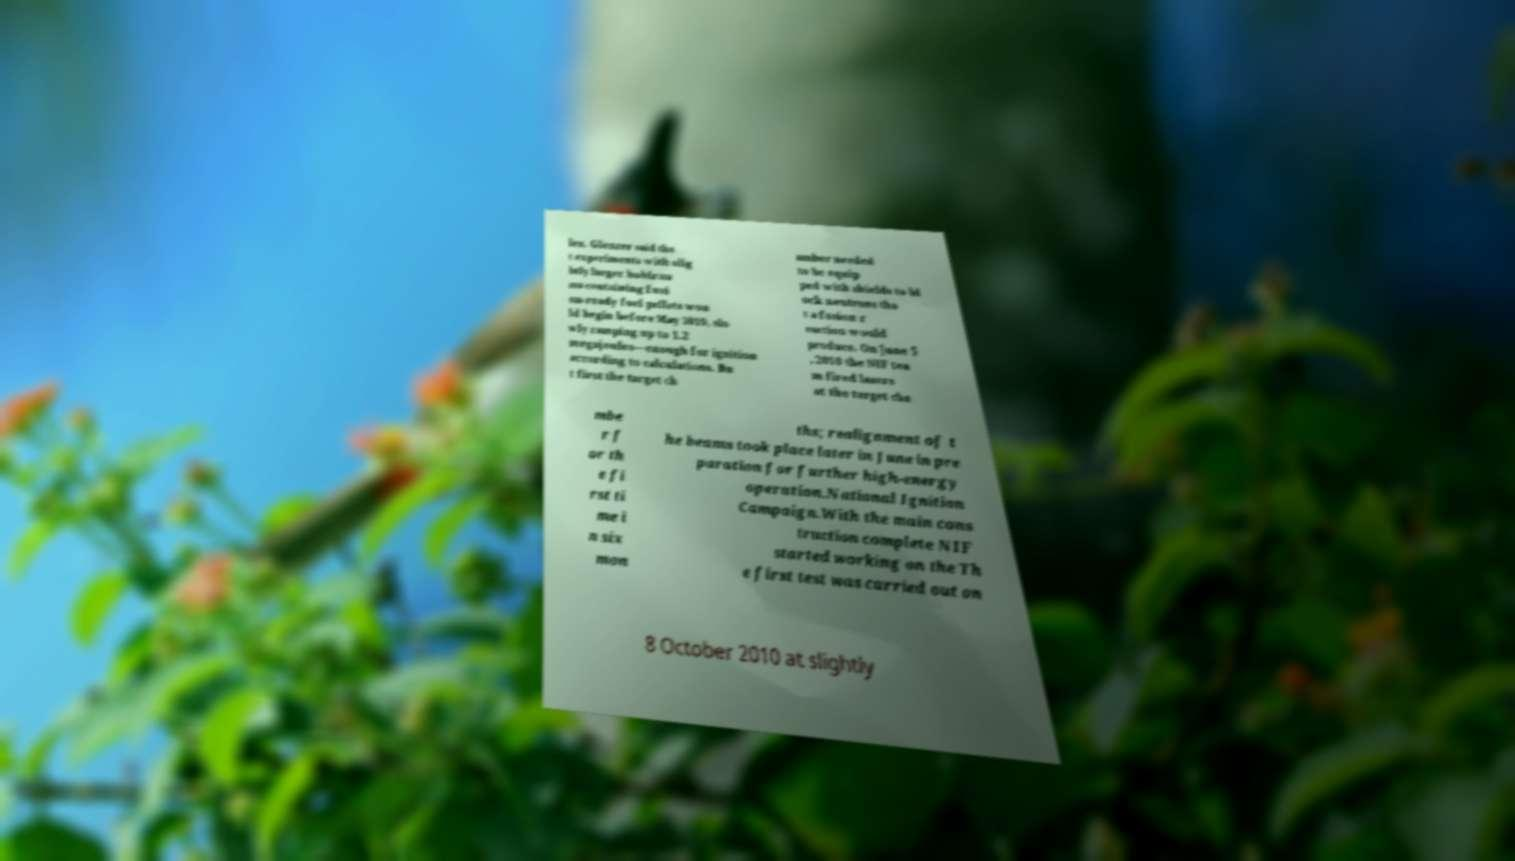Please read and relay the text visible in this image. What does it say? les. Glenzer said tha t experiments with slig htly larger hohlrau ms containing fusi on-ready fuel pellets wou ld begin before May 2010, slo wly ramping up to 1.2 megajoules—enough for ignition according to calculations. Bu t first the target ch amber needed to be equip ped with shields to bl ock neutrons tha t a fusion r eaction would produce. On June 5 , 2010 the NIF tea m fired lasers at the target cha mbe r f or th e fi rst ti me i n six mon ths; realignment of t he beams took place later in June in pre paration for further high-energy operation.National Ignition Campaign.With the main cons truction complete NIF started working on the Th e first test was carried out on 8 October 2010 at slightly 